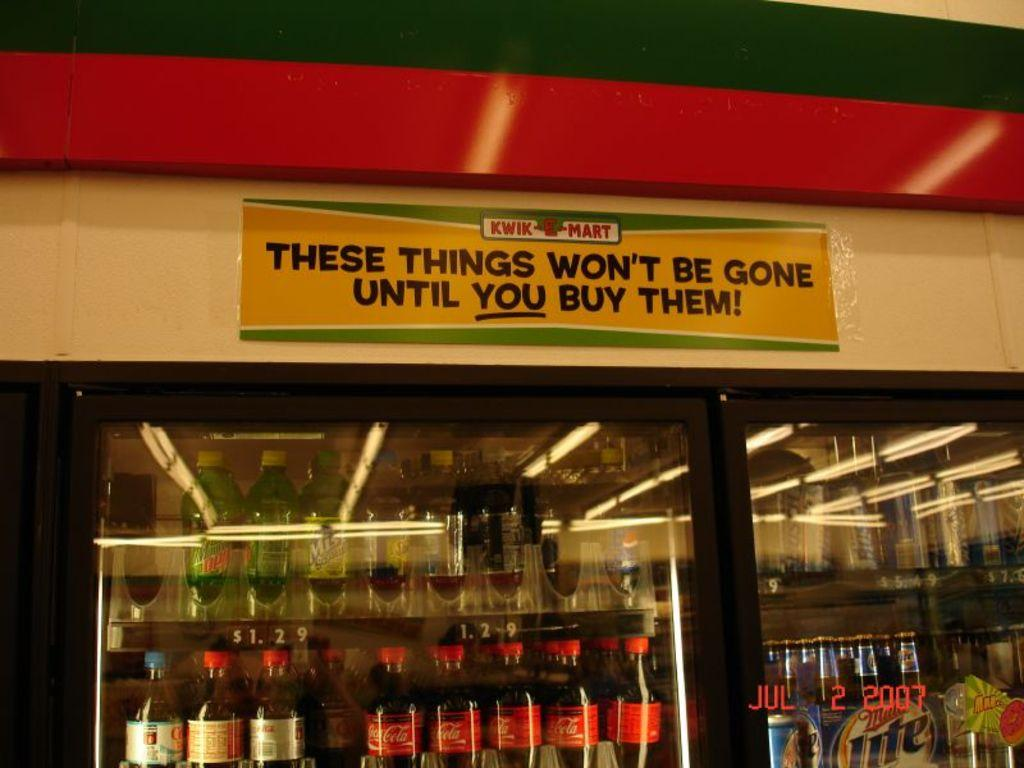<image>
Render a clear and concise summary of the photo. Beverages are for sale in a Kwik-E-Mart location. 